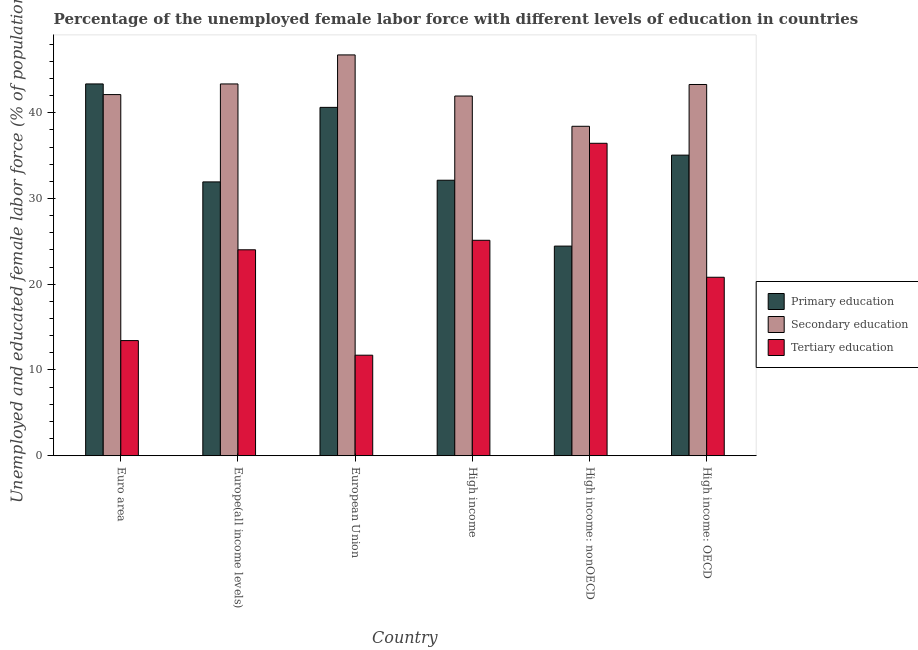How many different coloured bars are there?
Provide a short and direct response. 3. How many groups of bars are there?
Give a very brief answer. 6. Are the number of bars per tick equal to the number of legend labels?
Offer a terse response. Yes. Are the number of bars on each tick of the X-axis equal?
Offer a very short reply. Yes. How many bars are there on the 4th tick from the right?
Keep it short and to the point. 3. What is the label of the 5th group of bars from the left?
Ensure brevity in your answer.  High income: nonOECD. What is the percentage of female labor force who received secondary education in Europe(all income levels)?
Offer a terse response. 43.35. Across all countries, what is the maximum percentage of female labor force who received primary education?
Keep it short and to the point. 43.35. Across all countries, what is the minimum percentage of female labor force who received primary education?
Give a very brief answer. 24.44. In which country was the percentage of female labor force who received primary education maximum?
Give a very brief answer. Euro area. In which country was the percentage of female labor force who received secondary education minimum?
Offer a very short reply. High income: nonOECD. What is the total percentage of female labor force who received primary education in the graph?
Your response must be concise. 207.53. What is the difference between the percentage of female labor force who received tertiary education in Euro area and that in European Union?
Give a very brief answer. 1.7. What is the difference between the percentage of female labor force who received secondary education in Euro area and the percentage of female labor force who received primary education in High income?
Give a very brief answer. 9.99. What is the average percentage of female labor force who received primary education per country?
Offer a terse response. 34.59. What is the difference between the percentage of female labor force who received primary education and percentage of female labor force who received tertiary education in High income: OECD?
Your answer should be very brief. 14.24. What is the ratio of the percentage of female labor force who received primary education in European Union to that in High income: OECD?
Offer a very short reply. 1.16. What is the difference between the highest and the second highest percentage of female labor force who received primary education?
Make the answer very short. 2.73. What is the difference between the highest and the lowest percentage of female labor force who received primary education?
Provide a succinct answer. 18.91. Is the sum of the percentage of female labor force who received tertiary education in Euro area and High income: OECD greater than the maximum percentage of female labor force who received primary education across all countries?
Make the answer very short. No. What does the 1st bar from the left in European Union represents?
Your answer should be compact. Primary education. What does the 1st bar from the right in High income: nonOECD represents?
Your answer should be very brief. Tertiary education. Is it the case that in every country, the sum of the percentage of female labor force who received primary education and percentage of female labor force who received secondary education is greater than the percentage of female labor force who received tertiary education?
Ensure brevity in your answer.  Yes. Are all the bars in the graph horizontal?
Your response must be concise. No. Does the graph contain grids?
Your response must be concise. No. How many legend labels are there?
Your response must be concise. 3. How are the legend labels stacked?
Ensure brevity in your answer.  Vertical. What is the title of the graph?
Keep it short and to the point. Percentage of the unemployed female labor force with different levels of education in countries. Does "Negligence towards kids" appear as one of the legend labels in the graph?
Your answer should be compact. No. What is the label or title of the Y-axis?
Give a very brief answer. Unemployed and educated female labor force (% of population). What is the Unemployed and educated female labor force (% of population) in Primary education in Euro area?
Ensure brevity in your answer.  43.35. What is the Unemployed and educated female labor force (% of population) in Secondary education in Euro area?
Give a very brief answer. 42.11. What is the Unemployed and educated female labor force (% of population) in Tertiary education in Euro area?
Ensure brevity in your answer.  13.43. What is the Unemployed and educated female labor force (% of population) in Primary education in Europe(all income levels)?
Your response must be concise. 31.93. What is the Unemployed and educated female labor force (% of population) of Secondary education in Europe(all income levels)?
Offer a very short reply. 43.35. What is the Unemployed and educated female labor force (% of population) of Tertiary education in Europe(all income levels)?
Offer a very short reply. 24.01. What is the Unemployed and educated female labor force (% of population) in Primary education in European Union?
Make the answer very short. 40.62. What is the Unemployed and educated female labor force (% of population) of Secondary education in European Union?
Your answer should be very brief. 46.74. What is the Unemployed and educated female labor force (% of population) of Tertiary education in European Union?
Offer a very short reply. 11.72. What is the Unemployed and educated female labor force (% of population) of Primary education in High income?
Your response must be concise. 32.13. What is the Unemployed and educated female labor force (% of population) in Secondary education in High income?
Provide a short and direct response. 41.95. What is the Unemployed and educated female labor force (% of population) of Tertiary education in High income?
Keep it short and to the point. 25.12. What is the Unemployed and educated female labor force (% of population) in Primary education in High income: nonOECD?
Keep it short and to the point. 24.44. What is the Unemployed and educated female labor force (% of population) in Secondary education in High income: nonOECD?
Your answer should be compact. 38.42. What is the Unemployed and educated female labor force (% of population) in Tertiary education in High income: nonOECD?
Keep it short and to the point. 36.43. What is the Unemployed and educated female labor force (% of population) in Primary education in High income: OECD?
Your answer should be compact. 35.05. What is the Unemployed and educated female labor force (% of population) of Secondary education in High income: OECD?
Provide a succinct answer. 43.29. What is the Unemployed and educated female labor force (% of population) of Tertiary education in High income: OECD?
Offer a terse response. 20.81. Across all countries, what is the maximum Unemployed and educated female labor force (% of population) of Primary education?
Give a very brief answer. 43.35. Across all countries, what is the maximum Unemployed and educated female labor force (% of population) of Secondary education?
Ensure brevity in your answer.  46.74. Across all countries, what is the maximum Unemployed and educated female labor force (% of population) in Tertiary education?
Ensure brevity in your answer.  36.43. Across all countries, what is the minimum Unemployed and educated female labor force (% of population) in Primary education?
Give a very brief answer. 24.44. Across all countries, what is the minimum Unemployed and educated female labor force (% of population) in Secondary education?
Your response must be concise. 38.42. Across all countries, what is the minimum Unemployed and educated female labor force (% of population) in Tertiary education?
Keep it short and to the point. 11.72. What is the total Unemployed and educated female labor force (% of population) in Primary education in the graph?
Your answer should be very brief. 207.53. What is the total Unemployed and educated female labor force (% of population) of Secondary education in the graph?
Keep it short and to the point. 255.86. What is the total Unemployed and educated female labor force (% of population) of Tertiary education in the graph?
Your response must be concise. 131.53. What is the difference between the Unemployed and educated female labor force (% of population) of Primary education in Euro area and that in Europe(all income levels)?
Your answer should be compact. 11.42. What is the difference between the Unemployed and educated female labor force (% of population) of Secondary education in Euro area and that in Europe(all income levels)?
Provide a succinct answer. -1.24. What is the difference between the Unemployed and educated female labor force (% of population) in Tertiary education in Euro area and that in Europe(all income levels)?
Your answer should be compact. -10.59. What is the difference between the Unemployed and educated female labor force (% of population) in Primary education in Euro area and that in European Union?
Offer a terse response. 2.73. What is the difference between the Unemployed and educated female labor force (% of population) in Secondary education in Euro area and that in European Union?
Provide a succinct answer. -4.63. What is the difference between the Unemployed and educated female labor force (% of population) in Tertiary education in Euro area and that in European Union?
Your answer should be very brief. 1.7. What is the difference between the Unemployed and educated female labor force (% of population) in Primary education in Euro area and that in High income?
Keep it short and to the point. 11.23. What is the difference between the Unemployed and educated female labor force (% of population) of Secondary education in Euro area and that in High income?
Your answer should be compact. 0.17. What is the difference between the Unemployed and educated female labor force (% of population) in Tertiary education in Euro area and that in High income?
Your answer should be very brief. -11.7. What is the difference between the Unemployed and educated female labor force (% of population) of Primary education in Euro area and that in High income: nonOECD?
Provide a short and direct response. 18.91. What is the difference between the Unemployed and educated female labor force (% of population) of Secondary education in Euro area and that in High income: nonOECD?
Keep it short and to the point. 3.7. What is the difference between the Unemployed and educated female labor force (% of population) of Tertiary education in Euro area and that in High income: nonOECD?
Your answer should be very brief. -23.01. What is the difference between the Unemployed and educated female labor force (% of population) in Primary education in Euro area and that in High income: OECD?
Your answer should be compact. 8.3. What is the difference between the Unemployed and educated female labor force (% of population) of Secondary education in Euro area and that in High income: OECD?
Ensure brevity in your answer.  -1.18. What is the difference between the Unemployed and educated female labor force (% of population) of Tertiary education in Euro area and that in High income: OECD?
Ensure brevity in your answer.  -7.39. What is the difference between the Unemployed and educated female labor force (% of population) in Primary education in Europe(all income levels) and that in European Union?
Give a very brief answer. -8.69. What is the difference between the Unemployed and educated female labor force (% of population) in Secondary education in Europe(all income levels) and that in European Union?
Provide a succinct answer. -3.38. What is the difference between the Unemployed and educated female labor force (% of population) of Tertiary education in Europe(all income levels) and that in European Union?
Your answer should be compact. 12.29. What is the difference between the Unemployed and educated female labor force (% of population) of Primary education in Europe(all income levels) and that in High income?
Give a very brief answer. -0.2. What is the difference between the Unemployed and educated female labor force (% of population) in Secondary education in Europe(all income levels) and that in High income?
Your response must be concise. 1.41. What is the difference between the Unemployed and educated female labor force (% of population) in Tertiary education in Europe(all income levels) and that in High income?
Make the answer very short. -1.11. What is the difference between the Unemployed and educated female labor force (% of population) in Primary education in Europe(all income levels) and that in High income: nonOECD?
Offer a very short reply. 7.49. What is the difference between the Unemployed and educated female labor force (% of population) of Secondary education in Europe(all income levels) and that in High income: nonOECD?
Offer a terse response. 4.94. What is the difference between the Unemployed and educated female labor force (% of population) in Tertiary education in Europe(all income levels) and that in High income: nonOECD?
Offer a very short reply. -12.42. What is the difference between the Unemployed and educated female labor force (% of population) in Primary education in Europe(all income levels) and that in High income: OECD?
Your response must be concise. -3.12. What is the difference between the Unemployed and educated female labor force (% of population) in Secondary education in Europe(all income levels) and that in High income: OECD?
Your response must be concise. 0.06. What is the difference between the Unemployed and educated female labor force (% of population) in Tertiary education in Europe(all income levels) and that in High income: OECD?
Offer a terse response. 3.2. What is the difference between the Unemployed and educated female labor force (% of population) of Primary education in European Union and that in High income?
Give a very brief answer. 8.5. What is the difference between the Unemployed and educated female labor force (% of population) of Secondary education in European Union and that in High income?
Your response must be concise. 4.79. What is the difference between the Unemployed and educated female labor force (% of population) of Tertiary education in European Union and that in High income?
Give a very brief answer. -13.4. What is the difference between the Unemployed and educated female labor force (% of population) in Primary education in European Union and that in High income: nonOECD?
Provide a succinct answer. 16.18. What is the difference between the Unemployed and educated female labor force (% of population) of Secondary education in European Union and that in High income: nonOECD?
Ensure brevity in your answer.  8.32. What is the difference between the Unemployed and educated female labor force (% of population) in Tertiary education in European Union and that in High income: nonOECD?
Make the answer very short. -24.71. What is the difference between the Unemployed and educated female labor force (% of population) in Primary education in European Union and that in High income: OECD?
Ensure brevity in your answer.  5.57. What is the difference between the Unemployed and educated female labor force (% of population) of Secondary education in European Union and that in High income: OECD?
Your response must be concise. 3.45. What is the difference between the Unemployed and educated female labor force (% of population) of Tertiary education in European Union and that in High income: OECD?
Offer a terse response. -9.09. What is the difference between the Unemployed and educated female labor force (% of population) of Primary education in High income and that in High income: nonOECD?
Provide a succinct answer. 7.68. What is the difference between the Unemployed and educated female labor force (% of population) of Secondary education in High income and that in High income: nonOECD?
Your answer should be compact. 3.53. What is the difference between the Unemployed and educated female labor force (% of population) in Tertiary education in High income and that in High income: nonOECD?
Offer a very short reply. -11.31. What is the difference between the Unemployed and educated female labor force (% of population) of Primary education in High income and that in High income: OECD?
Keep it short and to the point. -2.93. What is the difference between the Unemployed and educated female labor force (% of population) of Secondary education in High income and that in High income: OECD?
Ensure brevity in your answer.  -1.34. What is the difference between the Unemployed and educated female labor force (% of population) of Tertiary education in High income and that in High income: OECD?
Provide a short and direct response. 4.31. What is the difference between the Unemployed and educated female labor force (% of population) in Primary education in High income: nonOECD and that in High income: OECD?
Your answer should be compact. -10.61. What is the difference between the Unemployed and educated female labor force (% of population) of Secondary education in High income: nonOECD and that in High income: OECD?
Your answer should be compact. -4.87. What is the difference between the Unemployed and educated female labor force (% of population) in Tertiary education in High income: nonOECD and that in High income: OECD?
Your answer should be compact. 15.62. What is the difference between the Unemployed and educated female labor force (% of population) in Primary education in Euro area and the Unemployed and educated female labor force (% of population) in Secondary education in Europe(all income levels)?
Offer a very short reply. 0. What is the difference between the Unemployed and educated female labor force (% of population) of Primary education in Euro area and the Unemployed and educated female labor force (% of population) of Tertiary education in Europe(all income levels)?
Your answer should be very brief. 19.34. What is the difference between the Unemployed and educated female labor force (% of population) of Secondary education in Euro area and the Unemployed and educated female labor force (% of population) of Tertiary education in Europe(all income levels)?
Offer a very short reply. 18.1. What is the difference between the Unemployed and educated female labor force (% of population) in Primary education in Euro area and the Unemployed and educated female labor force (% of population) in Secondary education in European Union?
Ensure brevity in your answer.  -3.38. What is the difference between the Unemployed and educated female labor force (% of population) of Primary education in Euro area and the Unemployed and educated female labor force (% of population) of Tertiary education in European Union?
Your response must be concise. 31.63. What is the difference between the Unemployed and educated female labor force (% of population) of Secondary education in Euro area and the Unemployed and educated female labor force (% of population) of Tertiary education in European Union?
Make the answer very short. 30.39. What is the difference between the Unemployed and educated female labor force (% of population) of Primary education in Euro area and the Unemployed and educated female labor force (% of population) of Secondary education in High income?
Your response must be concise. 1.41. What is the difference between the Unemployed and educated female labor force (% of population) of Primary education in Euro area and the Unemployed and educated female labor force (% of population) of Tertiary education in High income?
Provide a succinct answer. 18.23. What is the difference between the Unemployed and educated female labor force (% of population) of Secondary education in Euro area and the Unemployed and educated female labor force (% of population) of Tertiary education in High income?
Provide a succinct answer. 16.99. What is the difference between the Unemployed and educated female labor force (% of population) of Primary education in Euro area and the Unemployed and educated female labor force (% of population) of Secondary education in High income: nonOECD?
Offer a very short reply. 4.94. What is the difference between the Unemployed and educated female labor force (% of population) in Primary education in Euro area and the Unemployed and educated female labor force (% of population) in Tertiary education in High income: nonOECD?
Ensure brevity in your answer.  6.92. What is the difference between the Unemployed and educated female labor force (% of population) of Secondary education in Euro area and the Unemployed and educated female labor force (% of population) of Tertiary education in High income: nonOECD?
Your answer should be compact. 5.68. What is the difference between the Unemployed and educated female labor force (% of population) of Primary education in Euro area and the Unemployed and educated female labor force (% of population) of Secondary education in High income: OECD?
Your response must be concise. 0.06. What is the difference between the Unemployed and educated female labor force (% of population) in Primary education in Euro area and the Unemployed and educated female labor force (% of population) in Tertiary education in High income: OECD?
Your answer should be very brief. 22.54. What is the difference between the Unemployed and educated female labor force (% of population) of Secondary education in Euro area and the Unemployed and educated female labor force (% of population) of Tertiary education in High income: OECD?
Ensure brevity in your answer.  21.3. What is the difference between the Unemployed and educated female labor force (% of population) of Primary education in Europe(all income levels) and the Unemployed and educated female labor force (% of population) of Secondary education in European Union?
Make the answer very short. -14.81. What is the difference between the Unemployed and educated female labor force (% of population) in Primary education in Europe(all income levels) and the Unemployed and educated female labor force (% of population) in Tertiary education in European Union?
Your answer should be very brief. 20.21. What is the difference between the Unemployed and educated female labor force (% of population) of Secondary education in Europe(all income levels) and the Unemployed and educated female labor force (% of population) of Tertiary education in European Union?
Give a very brief answer. 31.63. What is the difference between the Unemployed and educated female labor force (% of population) of Primary education in Europe(all income levels) and the Unemployed and educated female labor force (% of population) of Secondary education in High income?
Your answer should be compact. -10.02. What is the difference between the Unemployed and educated female labor force (% of population) in Primary education in Europe(all income levels) and the Unemployed and educated female labor force (% of population) in Tertiary education in High income?
Offer a very short reply. 6.81. What is the difference between the Unemployed and educated female labor force (% of population) in Secondary education in Europe(all income levels) and the Unemployed and educated female labor force (% of population) in Tertiary education in High income?
Offer a very short reply. 18.23. What is the difference between the Unemployed and educated female labor force (% of population) of Primary education in Europe(all income levels) and the Unemployed and educated female labor force (% of population) of Secondary education in High income: nonOECD?
Offer a terse response. -6.49. What is the difference between the Unemployed and educated female labor force (% of population) in Primary education in Europe(all income levels) and the Unemployed and educated female labor force (% of population) in Tertiary education in High income: nonOECD?
Offer a terse response. -4.5. What is the difference between the Unemployed and educated female labor force (% of population) in Secondary education in Europe(all income levels) and the Unemployed and educated female labor force (% of population) in Tertiary education in High income: nonOECD?
Your answer should be compact. 6.92. What is the difference between the Unemployed and educated female labor force (% of population) of Primary education in Europe(all income levels) and the Unemployed and educated female labor force (% of population) of Secondary education in High income: OECD?
Provide a succinct answer. -11.36. What is the difference between the Unemployed and educated female labor force (% of population) in Primary education in Europe(all income levels) and the Unemployed and educated female labor force (% of population) in Tertiary education in High income: OECD?
Give a very brief answer. 11.12. What is the difference between the Unemployed and educated female labor force (% of population) in Secondary education in Europe(all income levels) and the Unemployed and educated female labor force (% of population) in Tertiary education in High income: OECD?
Offer a terse response. 22.54. What is the difference between the Unemployed and educated female labor force (% of population) of Primary education in European Union and the Unemployed and educated female labor force (% of population) of Secondary education in High income?
Provide a succinct answer. -1.32. What is the difference between the Unemployed and educated female labor force (% of population) in Primary education in European Union and the Unemployed and educated female labor force (% of population) in Tertiary education in High income?
Give a very brief answer. 15.5. What is the difference between the Unemployed and educated female labor force (% of population) of Secondary education in European Union and the Unemployed and educated female labor force (% of population) of Tertiary education in High income?
Provide a short and direct response. 21.62. What is the difference between the Unemployed and educated female labor force (% of population) of Primary education in European Union and the Unemployed and educated female labor force (% of population) of Secondary education in High income: nonOECD?
Offer a very short reply. 2.21. What is the difference between the Unemployed and educated female labor force (% of population) in Primary education in European Union and the Unemployed and educated female labor force (% of population) in Tertiary education in High income: nonOECD?
Provide a succinct answer. 4.19. What is the difference between the Unemployed and educated female labor force (% of population) in Secondary education in European Union and the Unemployed and educated female labor force (% of population) in Tertiary education in High income: nonOECD?
Your answer should be very brief. 10.3. What is the difference between the Unemployed and educated female labor force (% of population) of Primary education in European Union and the Unemployed and educated female labor force (% of population) of Secondary education in High income: OECD?
Provide a succinct answer. -2.67. What is the difference between the Unemployed and educated female labor force (% of population) in Primary education in European Union and the Unemployed and educated female labor force (% of population) in Tertiary education in High income: OECD?
Provide a short and direct response. 19.81. What is the difference between the Unemployed and educated female labor force (% of population) of Secondary education in European Union and the Unemployed and educated female labor force (% of population) of Tertiary education in High income: OECD?
Keep it short and to the point. 25.93. What is the difference between the Unemployed and educated female labor force (% of population) in Primary education in High income and the Unemployed and educated female labor force (% of population) in Secondary education in High income: nonOECD?
Your response must be concise. -6.29. What is the difference between the Unemployed and educated female labor force (% of population) in Primary education in High income and the Unemployed and educated female labor force (% of population) in Tertiary education in High income: nonOECD?
Your answer should be very brief. -4.31. What is the difference between the Unemployed and educated female labor force (% of population) of Secondary education in High income and the Unemployed and educated female labor force (% of population) of Tertiary education in High income: nonOECD?
Keep it short and to the point. 5.51. What is the difference between the Unemployed and educated female labor force (% of population) of Primary education in High income and the Unemployed and educated female labor force (% of population) of Secondary education in High income: OECD?
Give a very brief answer. -11.16. What is the difference between the Unemployed and educated female labor force (% of population) in Primary education in High income and the Unemployed and educated female labor force (% of population) in Tertiary education in High income: OECD?
Provide a short and direct response. 11.31. What is the difference between the Unemployed and educated female labor force (% of population) in Secondary education in High income and the Unemployed and educated female labor force (% of population) in Tertiary education in High income: OECD?
Give a very brief answer. 21.13. What is the difference between the Unemployed and educated female labor force (% of population) in Primary education in High income: nonOECD and the Unemployed and educated female labor force (% of population) in Secondary education in High income: OECD?
Provide a short and direct response. -18.85. What is the difference between the Unemployed and educated female labor force (% of population) of Primary education in High income: nonOECD and the Unemployed and educated female labor force (% of population) of Tertiary education in High income: OECD?
Give a very brief answer. 3.63. What is the difference between the Unemployed and educated female labor force (% of population) of Secondary education in High income: nonOECD and the Unemployed and educated female labor force (% of population) of Tertiary education in High income: OECD?
Make the answer very short. 17.6. What is the average Unemployed and educated female labor force (% of population) in Primary education per country?
Make the answer very short. 34.59. What is the average Unemployed and educated female labor force (% of population) of Secondary education per country?
Provide a short and direct response. 42.64. What is the average Unemployed and educated female labor force (% of population) in Tertiary education per country?
Give a very brief answer. 21.92. What is the difference between the Unemployed and educated female labor force (% of population) in Primary education and Unemployed and educated female labor force (% of population) in Secondary education in Euro area?
Offer a terse response. 1.24. What is the difference between the Unemployed and educated female labor force (% of population) in Primary education and Unemployed and educated female labor force (% of population) in Tertiary education in Euro area?
Ensure brevity in your answer.  29.93. What is the difference between the Unemployed and educated female labor force (% of population) of Secondary education and Unemployed and educated female labor force (% of population) of Tertiary education in Euro area?
Offer a terse response. 28.69. What is the difference between the Unemployed and educated female labor force (% of population) in Primary education and Unemployed and educated female labor force (% of population) in Secondary education in Europe(all income levels)?
Give a very brief answer. -11.42. What is the difference between the Unemployed and educated female labor force (% of population) in Primary education and Unemployed and educated female labor force (% of population) in Tertiary education in Europe(all income levels)?
Give a very brief answer. 7.92. What is the difference between the Unemployed and educated female labor force (% of population) in Secondary education and Unemployed and educated female labor force (% of population) in Tertiary education in Europe(all income levels)?
Give a very brief answer. 19.34. What is the difference between the Unemployed and educated female labor force (% of population) in Primary education and Unemployed and educated female labor force (% of population) in Secondary education in European Union?
Ensure brevity in your answer.  -6.12. What is the difference between the Unemployed and educated female labor force (% of population) in Primary education and Unemployed and educated female labor force (% of population) in Tertiary education in European Union?
Offer a very short reply. 28.9. What is the difference between the Unemployed and educated female labor force (% of population) of Secondary education and Unemployed and educated female labor force (% of population) of Tertiary education in European Union?
Offer a very short reply. 35.02. What is the difference between the Unemployed and educated female labor force (% of population) of Primary education and Unemployed and educated female labor force (% of population) of Secondary education in High income?
Give a very brief answer. -9.82. What is the difference between the Unemployed and educated female labor force (% of population) of Primary education and Unemployed and educated female labor force (% of population) of Tertiary education in High income?
Provide a short and direct response. 7. What is the difference between the Unemployed and educated female labor force (% of population) of Secondary education and Unemployed and educated female labor force (% of population) of Tertiary education in High income?
Provide a short and direct response. 16.82. What is the difference between the Unemployed and educated female labor force (% of population) in Primary education and Unemployed and educated female labor force (% of population) in Secondary education in High income: nonOECD?
Provide a succinct answer. -13.97. What is the difference between the Unemployed and educated female labor force (% of population) of Primary education and Unemployed and educated female labor force (% of population) of Tertiary education in High income: nonOECD?
Offer a very short reply. -11.99. What is the difference between the Unemployed and educated female labor force (% of population) in Secondary education and Unemployed and educated female labor force (% of population) in Tertiary education in High income: nonOECD?
Offer a terse response. 1.98. What is the difference between the Unemployed and educated female labor force (% of population) of Primary education and Unemployed and educated female labor force (% of population) of Secondary education in High income: OECD?
Your answer should be compact. -8.24. What is the difference between the Unemployed and educated female labor force (% of population) in Primary education and Unemployed and educated female labor force (% of population) in Tertiary education in High income: OECD?
Give a very brief answer. 14.24. What is the difference between the Unemployed and educated female labor force (% of population) of Secondary education and Unemployed and educated female labor force (% of population) of Tertiary education in High income: OECD?
Offer a very short reply. 22.48. What is the ratio of the Unemployed and educated female labor force (% of population) in Primary education in Euro area to that in Europe(all income levels)?
Give a very brief answer. 1.36. What is the ratio of the Unemployed and educated female labor force (% of population) of Secondary education in Euro area to that in Europe(all income levels)?
Offer a terse response. 0.97. What is the ratio of the Unemployed and educated female labor force (% of population) in Tertiary education in Euro area to that in Europe(all income levels)?
Your answer should be very brief. 0.56. What is the ratio of the Unemployed and educated female labor force (% of population) in Primary education in Euro area to that in European Union?
Give a very brief answer. 1.07. What is the ratio of the Unemployed and educated female labor force (% of population) in Secondary education in Euro area to that in European Union?
Keep it short and to the point. 0.9. What is the ratio of the Unemployed and educated female labor force (% of population) of Tertiary education in Euro area to that in European Union?
Provide a succinct answer. 1.15. What is the ratio of the Unemployed and educated female labor force (% of population) in Primary education in Euro area to that in High income?
Give a very brief answer. 1.35. What is the ratio of the Unemployed and educated female labor force (% of population) of Secondary education in Euro area to that in High income?
Make the answer very short. 1. What is the ratio of the Unemployed and educated female labor force (% of population) in Tertiary education in Euro area to that in High income?
Provide a succinct answer. 0.53. What is the ratio of the Unemployed and educated female labor force (% of population) of Primary education in Euro area to that in High income: nonOECD?
Offer a terse response. 1.77. What is the ratio of the Unemployed and educated female labor force (% of population) of Secondary education in Euro area to that in High income: nonOECD?
Ensure brevity in your answer.  1.1. What is the ratio of the Unemployed and educated female labor force (% of population) in Tertiary education in Euro area to that in High income: nonOECD?
Your response must be concise. 0.37. What is the ratio of the Unemployed and educated female labor force (% of population) in Primary education in Euro area to that in High income: OECD?
Your answer should be very brief. 1.24. What is the ratio of the Unemployed and educated female labor force (% of population) in Secondary education in Euro area to that in High income: OECD?
Make the answer very short. 0.97. What is the ratio of the Unemployed and educated female labor force (% of population) in Tertiary education in Euro area to that in High income: OECD?
Provide a succinct answer. 0.65. What is the ratio of the Unemployed and educated female labor force (% of population) in Primary education in Europe(all income levels) to that in European Union?
Your answer should be very brief. 0.79. What is the ratio of the Unemployed and educated female labor force (% of population) of Secondary education in Europe(all income levels) to that in European Union?
Provide a succinct answer. 0.93. What is the ratio of the Unemployed and educated female labor force (% of population) of Tertiary education in Europe(all income levels) to that in European Union?
Your answer should be compact. 2.05. What is the ratio of the Unemployed and educated female labor force (% of population) in Primary education in Europe(all income levels) to that in High income?
Your response must be concise. 0.99. What is the ratio of the Unemployed and educated female labor force (% of population) in Secondary education in Europe(all income levels) to that in High income?
Your answer should be very brief. 1.03. What is the ratio of the Unemployed and educated female labor force (% of population) in Tertiary education in Europe(all income levels) to that in High income?
Keep it short and to the point. 0.96. What is the ratio of the Unemployed and educated female labor force (% of population) of Primary education in Europe(all income levels) to that in High income: nonOECD?
Ensure brevity in your answer.  1.31. What is the ratio of the Unemployed and educated female labor force (% of population) in Secondary education in Europe(all income levels) to that in High income: nonOECD?
Your answer should be compact. 1.13. What is the ratio of the Unemployed and educated female labor force (% of population) of Tertiary education in Europe(all income levels) to that in High income: nonOECD?
Provide a succinct answer. 0.66. What is the ratio of the Unemployed and educated female labor force (% of population) in Primary education in Europe(all income levels) to that in High income: OECD?
Give a very brief answer. 0.91. What is the ratio of the Unemployed and educated female labor force (% of population) of Secondary education in Europe(all income levels) to that in High income: OECD?
Provide a short and direct response. 1. What is the ratio of the Unemployed and educated female labor force (% of population) of Tertiary education in Europe(all income levels) to that in High income: OECD?
Your response must be concise. 1.15. What is the ratio of the Unemployed and educated female labor force (% of population) of Primary education in European Union to that in High income?
Offer a terse response. 1.26. What is the ratio of the Unemployed and educated female labor force (% of population) in Secondary education in European Union to that in High income?
Provide a short and direct response. 1.11. What is the ratio of the Unemployed and educated female labor force (% of population) of Tertiary education in European Union to that in High income?
Give a very brief answer. 0.47. What is the ratio of the Unemployed and educated female labor force (% of population) of Primary education in European Union to that in High income: nonOECD?
Make the answer very short. 1.66. What is the ratio of the Unemployed and educated female labor force (% of population) of Secondary education in European Union to that in High income: nonOECD?
Make the answer very short. 1.22. What is the ratio of the Unemployed and educated female labor force (% of population) of Tertiary education in European Union to that in High income: nonOECD?
Your answer should be compact. 0.32. What is the ratio of the Unemployed and educated female labor force (% of population) of Primary education in European Union to that in High income: OECD?
Keep it short and to the point. 1.16. What is the ratio of the Unemployed and educated female labor force (% of population) in Secondary education in European Union to that in High income: OECD?
Ensure brevity in your answer.  1.08. What is the ratio of the Unemployed and educated female labor force (% of population) in Tertiary education in European Union to that in High income: OECD?
Keep it short and to the point. 0.56. What is the ratio of the Unemployed and educated female labor force (% of population) in Primary education in High income to that in High income: nonOECD?
Provide a succinct answer. 1.31. What is the ratio of the Unemployed and educated female labor force (% of population) in Secondary education in High income to that in High income: nonOECD?
Provide a short and direct response. 1.09. What is the ratio of the Unemployed and educated female labor force (% of population) of Tertiary education in High income to that in High income: nonOECD?
Provide a succinct answer. 0.69. What is the ratio of the Unemployed and educated female labor force (% of population) of Primary education in High income to that in High income: OECD?
Your answer should be compact. 0.92. What is the ratio of the Unemployed and educated female labor force (% of population) of Secondary education in High income to that in High income: OECD?
Provide a short and direct response. 0.97. What is the ratio of the Unemployed and educated female labor force (% of population) of Tertiary education in High income to that in High income: OECD?
Offer a very short reply. 1.21. What is the ratio of the Unemployed and educated female labor force (% of population) in Primary education in High income: nonOECD to that in High income: OECD?
Keep it short and to the point. 0.7. What is the ratio of the Unemployed and educated female labor force (% of population) of Secondary education in High income: nonOECD to that in High income: OECD?
Provide a short and direct response. 0.89. What is the ratio of the Unemployed and educated female labor force (% of population) in Tertiary education in High income: nonOECD to that in High income: OECD?
Offer a terse response. 1.75. What is the difference between the highest and the second highest Unemployed and educated female labor force (% of population) in Primary education?
Ensure brevity in your answer.  2.73. What is the difference between the highest and the second highest Unemployed and educated female labor force (% of population) of Secondary education?
Provide a succinct answer. 3.38. What is the difference between the highest and the second highest Unemployed and educated female labor force (% of population) of Tertiary education?
Your answer should be compact. 11.31. What is the difference between the highest and the lowest Unemployed and educated female labor force (% of population) of Primary education?
Your answer should be compact. 18.91. What is the difference between the highest and the lowest Unemployed and educated female labor force (% of population) of Secondary education?
Ensure brevity in your answer.  8.32. What is the difference between the highest and the lowest Unemployed and educated female labor force (% of population) of Tertiary education?
Your answer should be very brief. 24.71. 